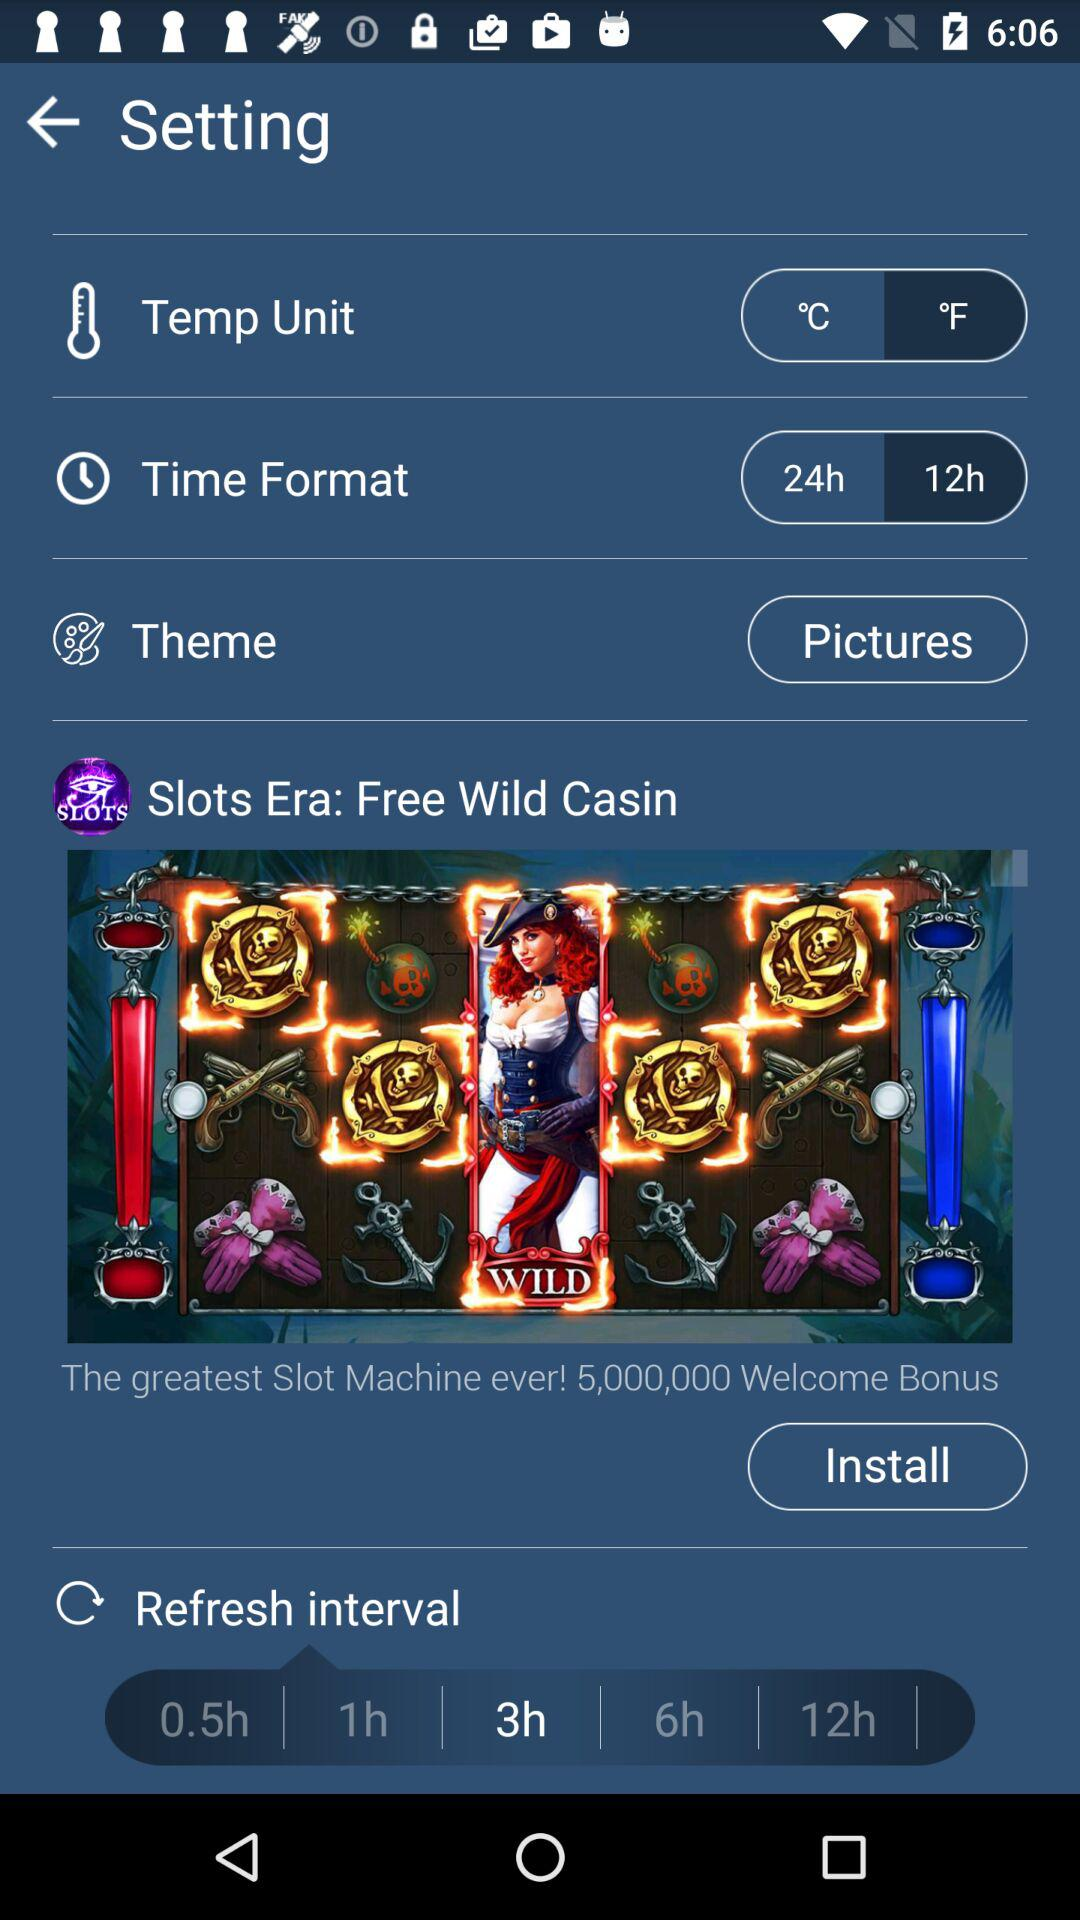What is the selected time format? The selected time format is 24 hours. 